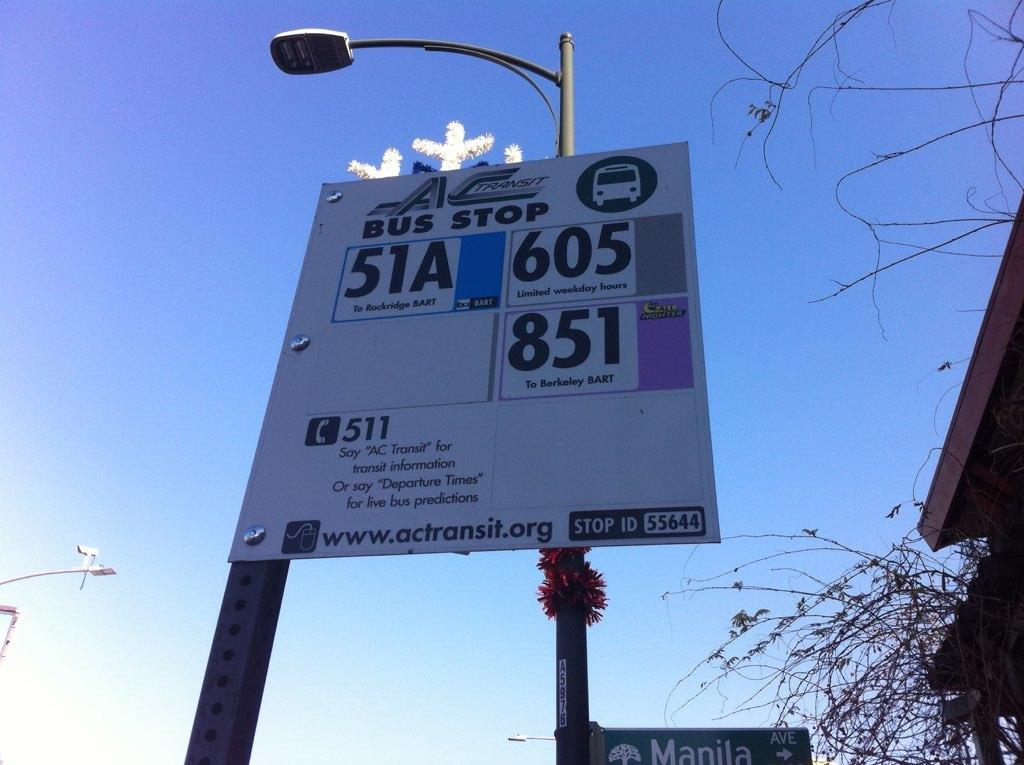<image>
Relay a brief, clear account of the picture shown. An outdoor billboard with a bus stop number on it. 